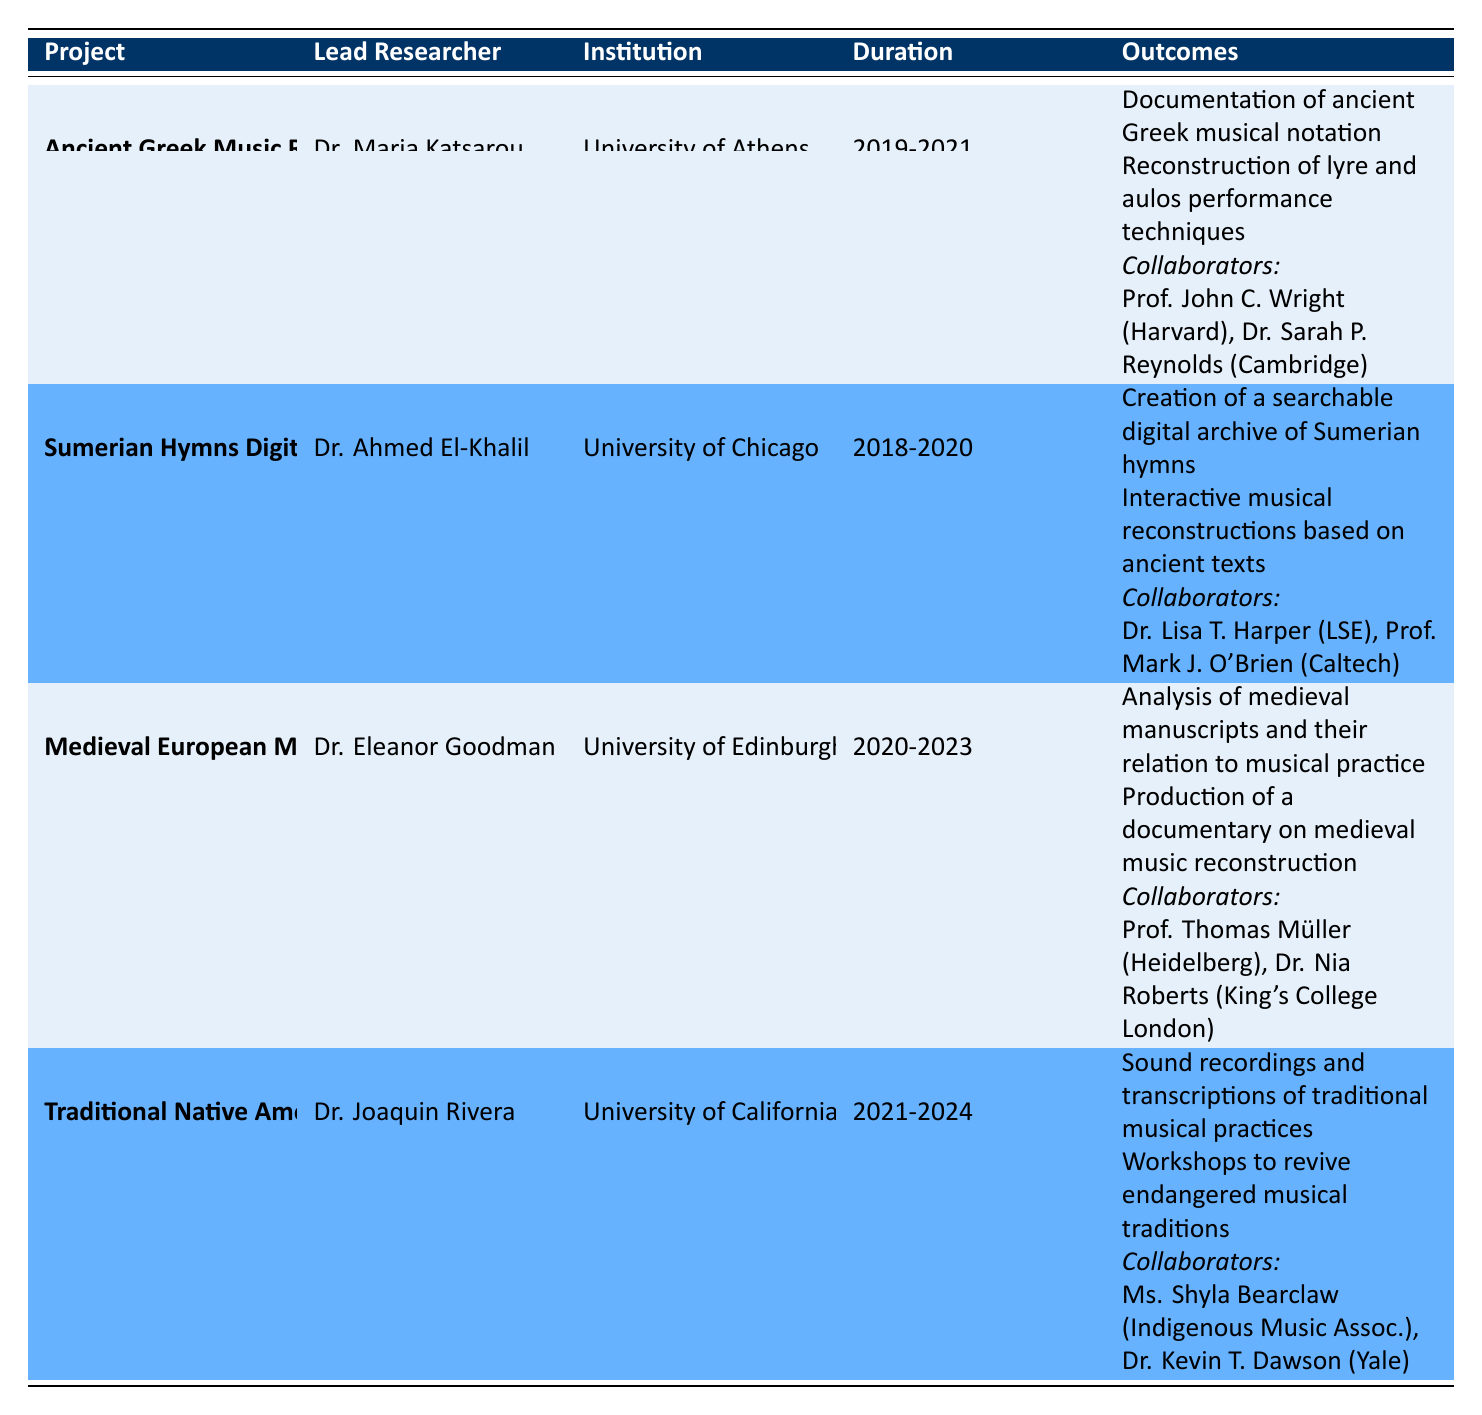What is the duration of the "Sumerian Hymns Digital Archive" project? The table indicates that the duration for the "Sumerian Hymns Digital Archive" project is from 2018 to 2020.
Answer: 2018-2020 Who is the lead researcher for the "Traditional Native American Music" project? According to the table, the lead researcher for the "Traditional Native American Music" project is Dr. Joaquin Rivera.
Answer: Dr. Joaquin Rivera Which institutions are involved in the "Medieval European Music Project"? The table shows that the "Medieval European Music Project" involves the University of Edinburgh as the lead institution, and it also lists University of Heidelberg and King's College London as the institutions of the collaborators.
Answer: University of Edinburgh, University of Heidelberg, King's College London Is there a project that focuses on creating a digital archive? The table lists a project titled "Sumerian Hymns Digital Archive," which explicitly indicates a focus on creating a digital archive of Sumerian hymns.
Answer: Yes How many collaborators participated in the "Ancient Greek Music Revival"? The table specifies that there are two collaborators in the "Ancient Greek Music Revival" project: Professor John C. Wright and Dr. Sarah P. Reynolds.
Answer: 2 Which project has the outcome of producing a documentary? The "Medieval European Music Project" has the outcome of producing a documentary on medieval music reconstruction as stated in the table.
Answer: Medieval European Music Project What is the average duration of the projects listed in the table? The durations provided are 2 years for "Ancient Greek Music Revival," 2 years for "Sumerian Hymns Digital Archive," 3 years for "Medieval European Music Project," and 4 years for "Traditional Native American Music." The total duration is 11 years across 4 projects, so the average is 11/4 = 2.75 years.
Answer: 2.75 years How many total collaborators worked across all projects listed? The table lists two collaborators for the "Ancient Greek Music Revival," two for the "Sumerian Hymns Digital Archive," two for the "Medieval European Music Project," and two for the "Traditional Native American Music." Adding them gives a total of 2 + 2 + 2 + 2 = 8 collaborators.
Answer: 8 Did any project involve an ethnomusicologist? The "Traditional Native American Music" project has Dr. Kevin T. Dawson as an ethnomusicologist, as per the information in the table.
Answer: Yes 